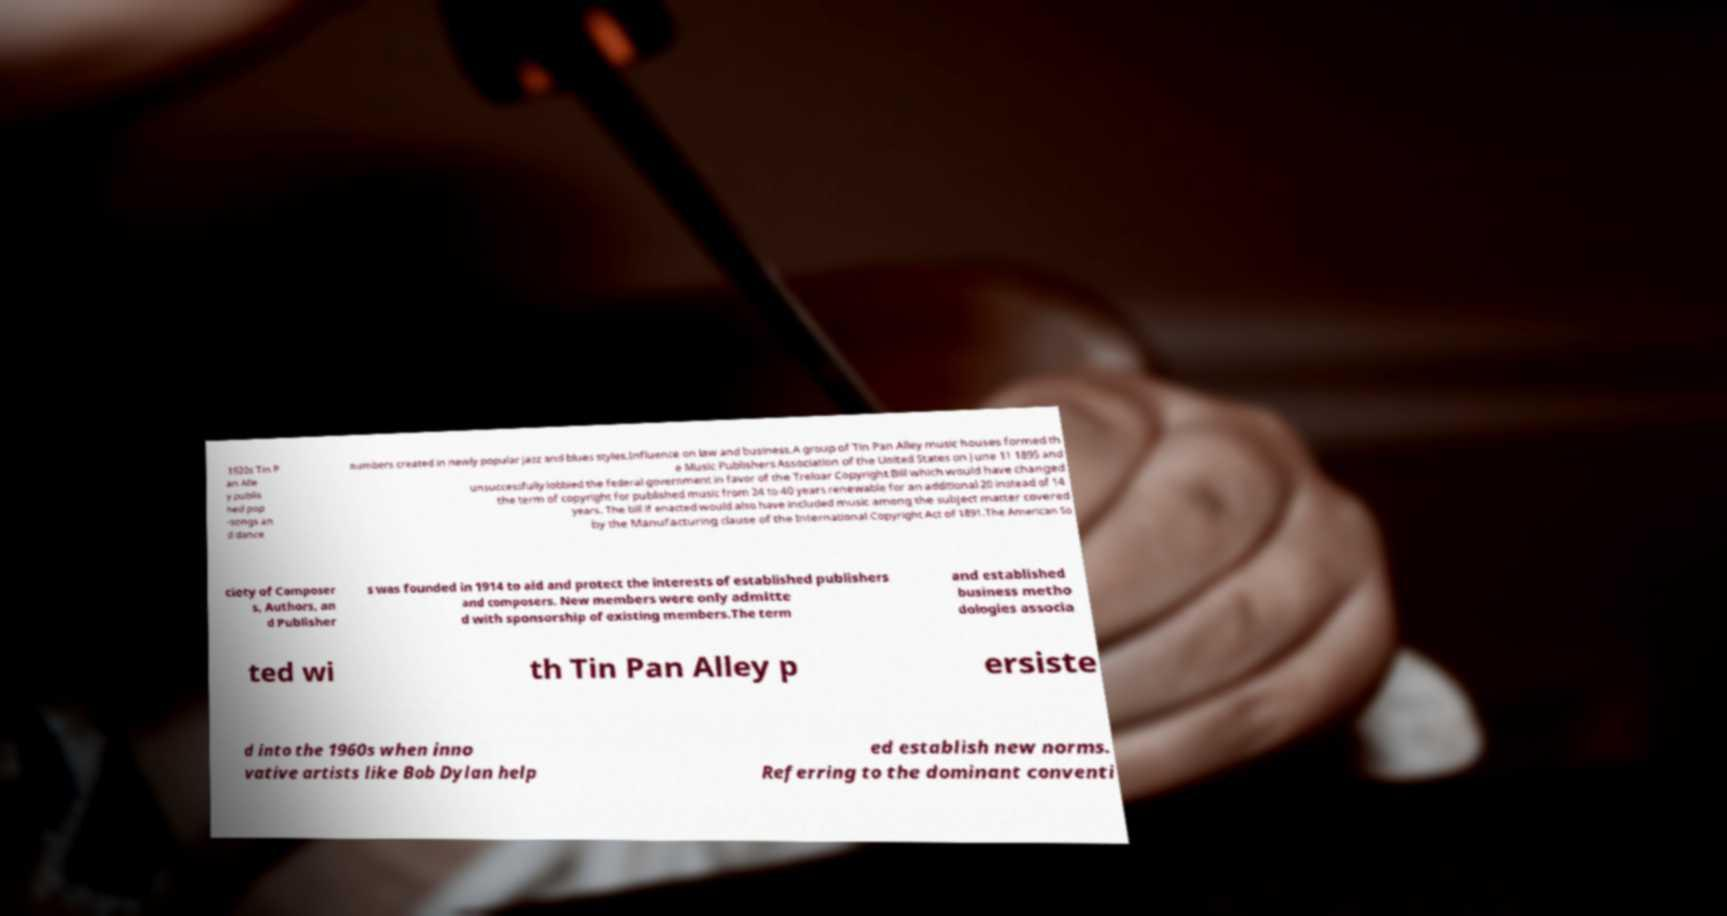Can you read and provide the text displayed in the image?This photo seems to have some interesting text. Can you extract and type it out for me? 1920s Tin P an Alle y publis hed pop -songs an d dance numbers created in newly popular jazz and blues styles.Influence on law and business.A group of Tin Pan Alley music houses formed th e Music Publishers Association of the United States on June 11 1895 and unsuccessfully lobbied the federal government in favor of the Treloar Copyright Bill which would have changed the term of copyright for published music from 24 to 40 years renewable for an additional 20 instead of 14 years. The bill if enacted would also have included music among the subject matter covered by the Manufacturing clause of the International Copyright Act of 1891.The American So ciety of Composer s, Authors, an d Publisher s was founded in 1914 to aid and protect the interests of established publishers and composers. New members were only admitte d with sponsorship of existing members.The term and established business metho dologies associa ted wi th Tin Pan Alley p ersiste d into the 1960s when inno vative artists like Bob Dylan help ed establish new norms. Referring to the dominant conventi 